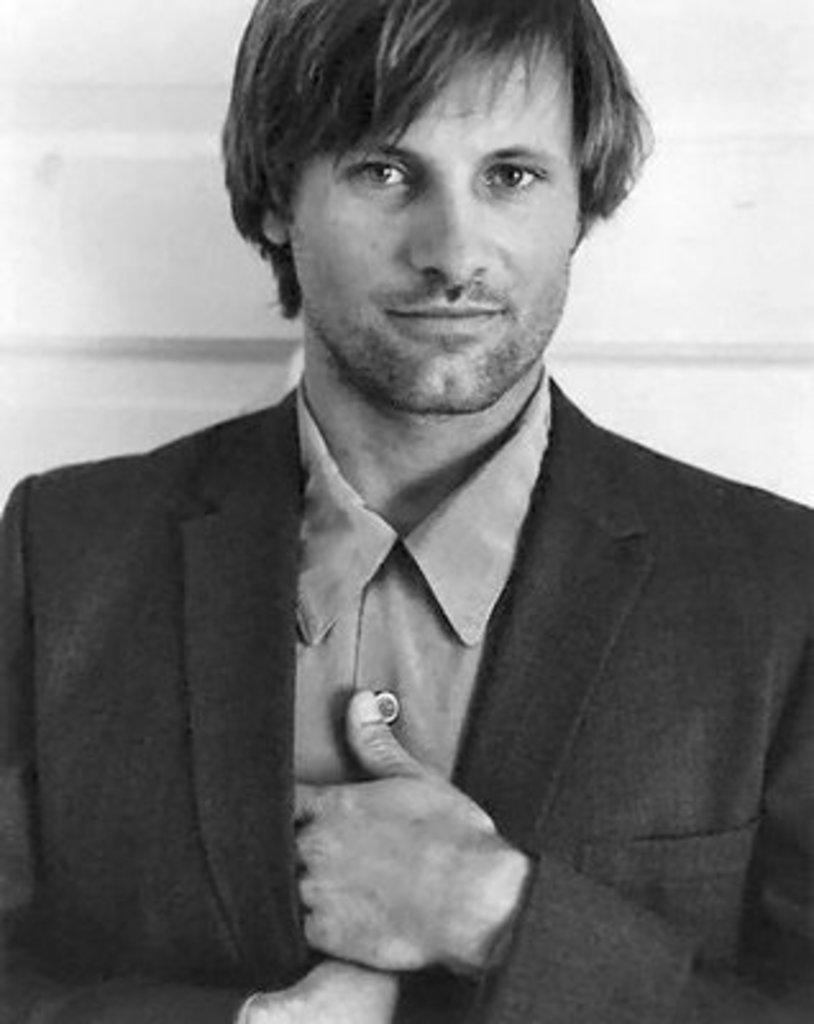What is the color scheme of the image? The image is black and white. Can you describe the main subject in the image? There is a person in the image. What is the person doing in the image? The person is watching something. What type of smell can be detected from the person in the image? There is no information about smells in the image, as it is a visual medium. 